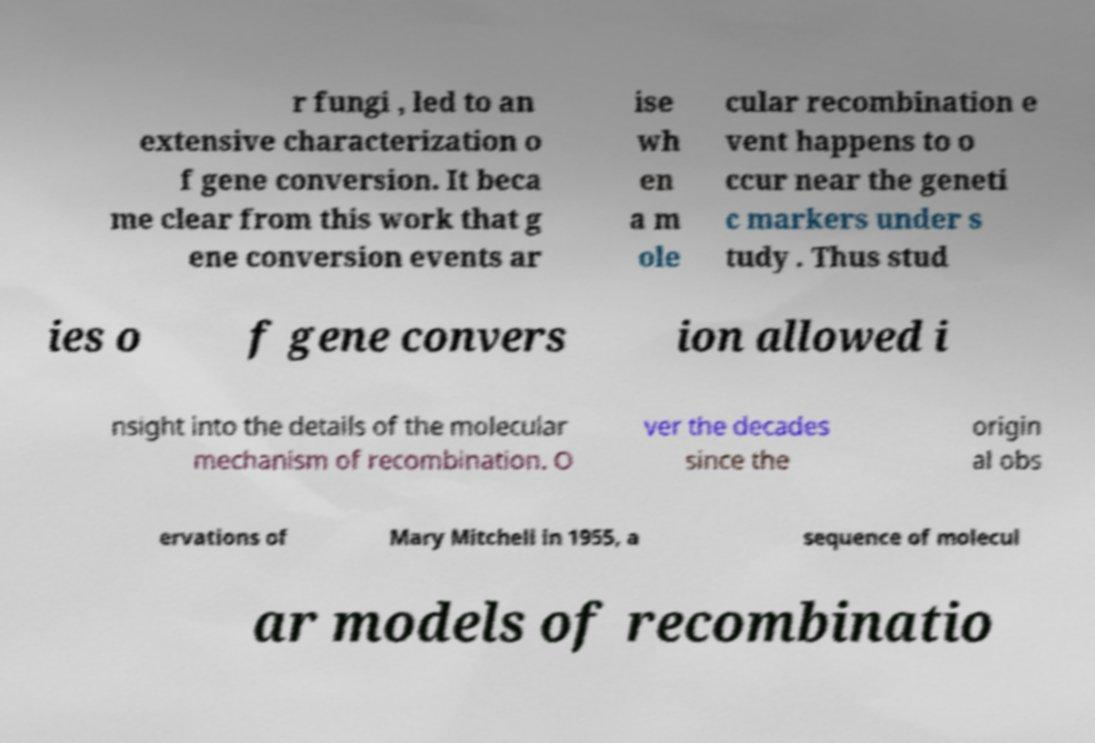Can you read and provide the text displayed in the image?This photo seems to have some interesting text. Can you extract and type it out for me? r fungi , led to an extensive characterization o f gene conversion. It beca me clear from this work that g ene conversion events ar ise wh en a m ole cular recombination e vent happens to o ccur near the geneti c markers under s tudy . Thus stud ies o f gene convers ion allowed i nsight into the details of the molecular mechanism of recombination. O ver the decades since the origin al obs ervations of Mary Mitchell in 1955, a sequence of molecul ar models of recombinatio 